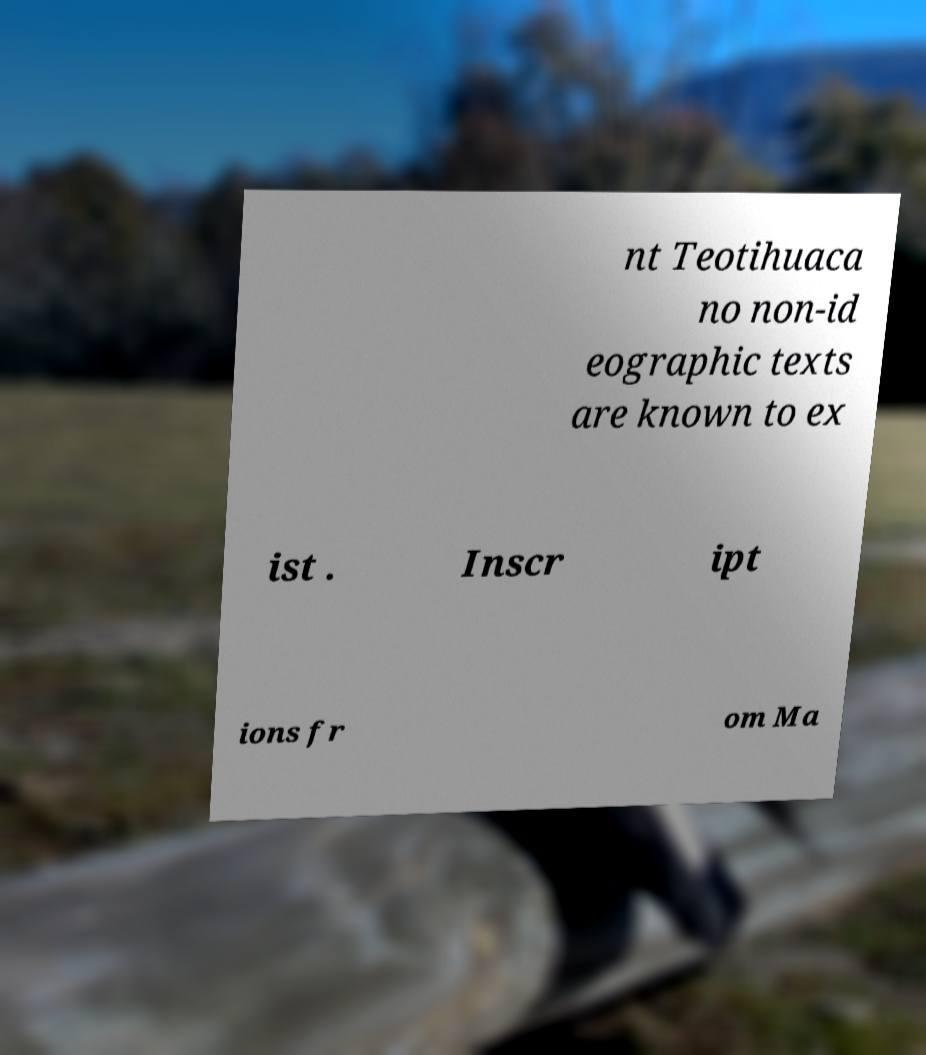Could you extract and type out the text from this image? nt Teotihuaca no non-id eographic texts are known to ex ist . Inscr ipt ions fr om Ma 